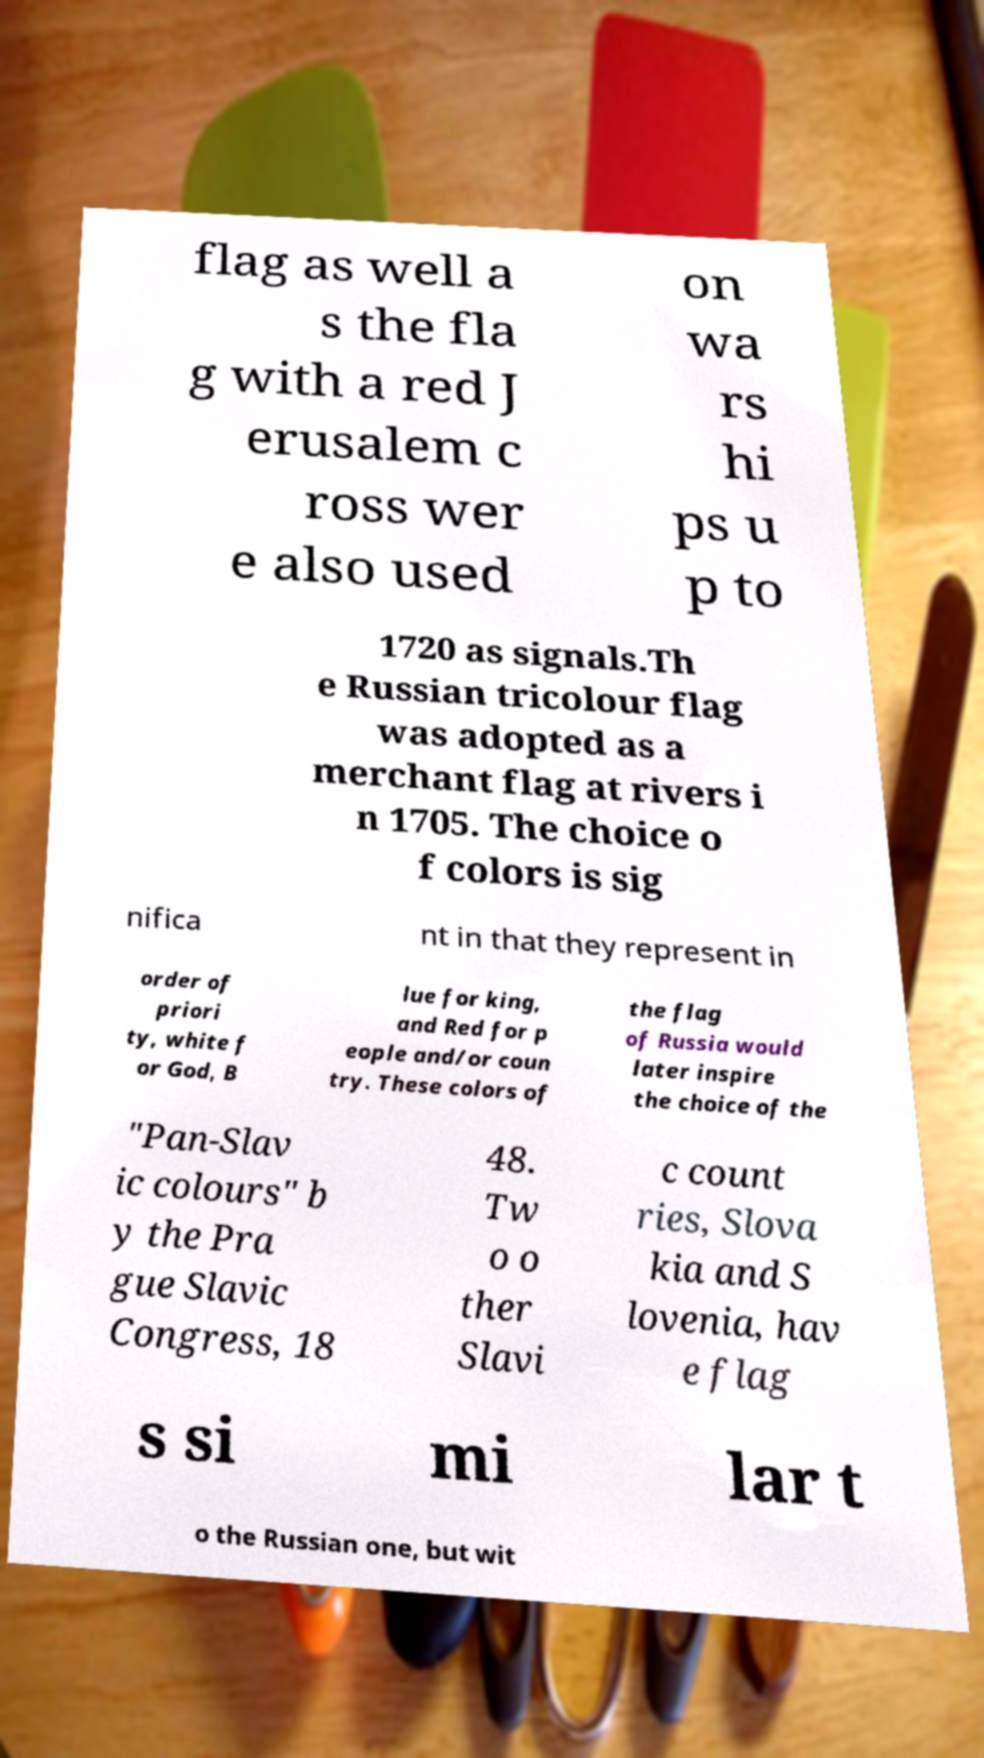What messages or text are displayed in this image? I need them in a readable, typed format. flag as well a s the fla g with a red J erusalem c ross wer e also used on wa rs hi ps u p to 1720 as signals.Th e Russian tricolour flag was adopted as a merchant flag at rivers i n 1705. The choice o f colors is sig nifica nt in that they represent in order of priori ty, white f or God, B lue for king, and Red for p eople and/or coun try. These colors of the flag of Russia would later inspire the choice of the "Pan-Slav ic colours" b y the Pra gue Slavic Congress, 18 48. Tw o o ther Slavi c count ries, Slova kia and S lovenia, hav e flag s si mi lar t o the Russian one, but wit 